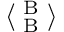Convert formula to latex. <formula><loc_0><loc_0><loc_500><loc_500>\langle _ { B } ^ { B } \rangle</formula> 